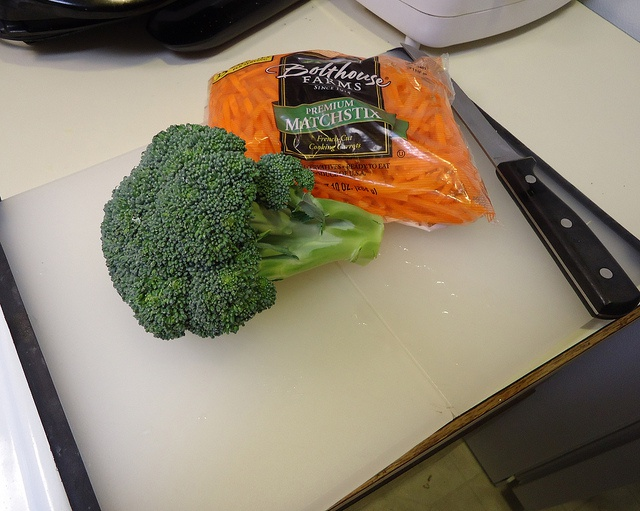Describe the objects in this image and their specific colors. I can see broccoli in black and darkgreen tones, carrot in black, red, and salmon tones, and knife in black and gray tones in this image. 